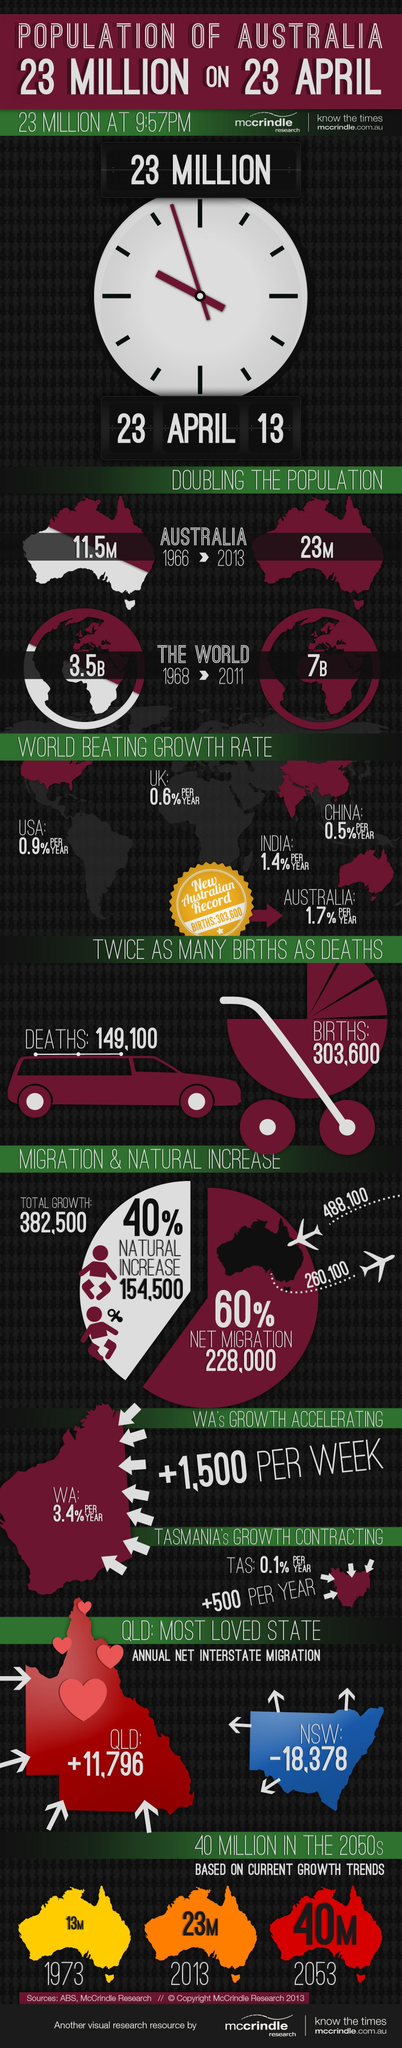What is the difference between the population in 2013 and 1973?
Answer the question with a short phrase. 10M What is the difference between the population in 2053 and 2013? 17M What is the difference between the population in 2053 and 1973? 27M 